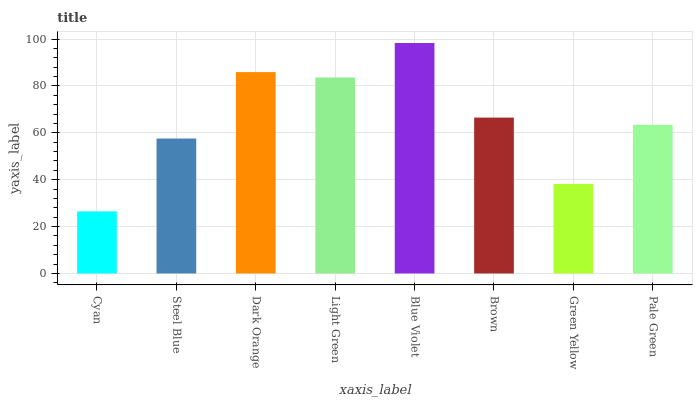Is Cyan the minimum?
Answer yes or no. Yes. Is Blue Violet the maximum?
Answer yes or no. Yes. Is Steel Blue the minimum?
Answer yes or no. No. Is Steel Blue the maximum?
Answer yes or no. No. Is Steel Blue greater than Cyan?
Answer yes or no. Yes. Is Cyan less than Steel Blue?
Answer yes or no. Yes. Is Cyan greater than Steel Blue?
Answer yes or no. No. Is Steel Blue less than Cyan?
Answer yes or no. No. Is Brown the high median?
Answer yes or no. Yes. Is Pale Green the low median?
Answer yes or no. Yes. Is Green Yellow the high median?
Answer yes or no. No. Is Blue Violet the low median?
Answer yes or no. No. 